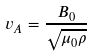Convert formula to latex. <formula><loc_0><loc_0><loc_500><loc_500>v _ { A } = { \frac { B _ { 0 } } { \sqrt { \mu _ { 0 } \rho } } }</formula> 